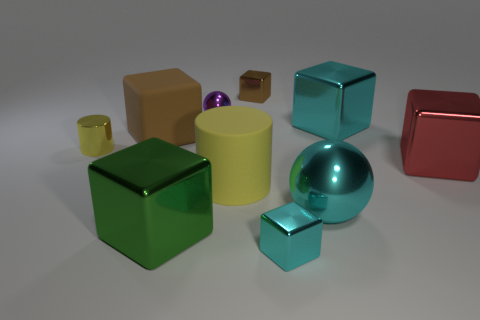Subtract 3 cubes. How many cubes are left? 3 Subtract all green cubes. How many cubes are left? 5 Subtract all big matte cubes. How many cubes are left? 5 Subtract all purple blocks. Subtract all blue spheres. How many blocks are left? 6 Subtract all balls. How many objects are left? 8 Subtract 0 purple cylinders. How many objects are left? 10 Subtract all cyan objects. Subtract all small brown things. How many objects are left? 6 Add 2 tiny cyan metal objects. How many tiny cyan metal objects are left? 3 Add 8 large yellow things. How many large yellow things exist? 9 